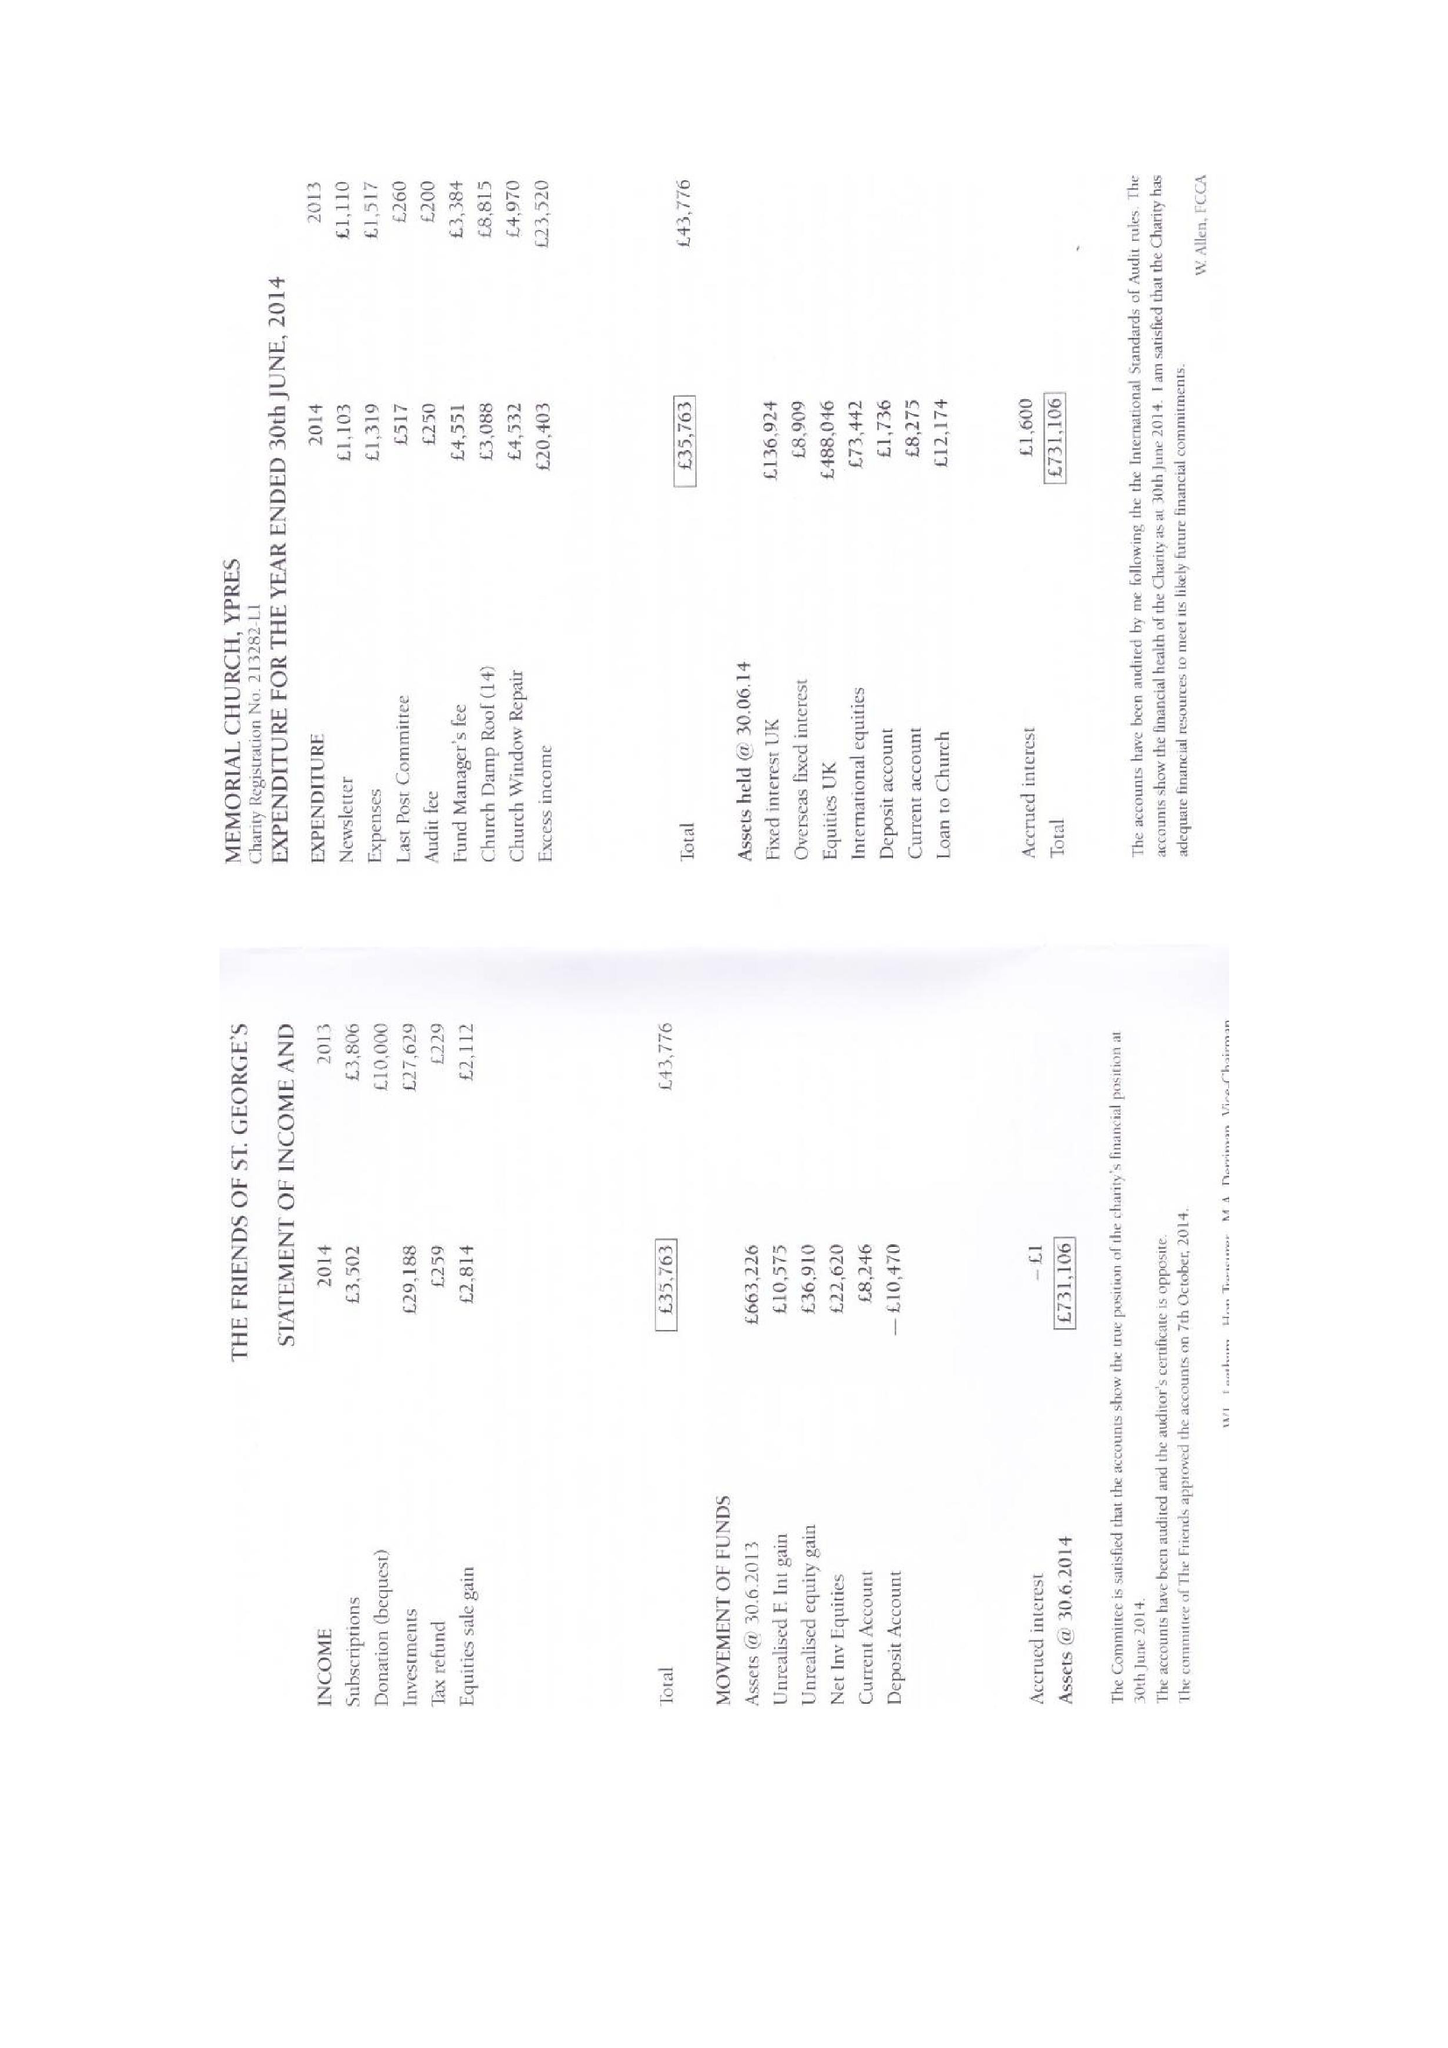What is the value for the income_annually_in_british_pounds?
Answer the question using a single word or phrase. 35763.00 